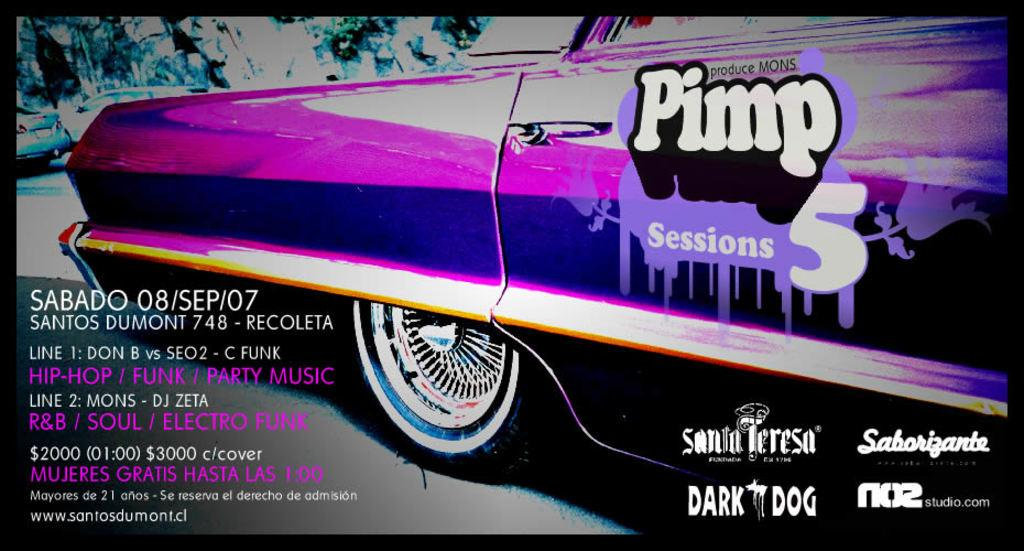What type of image is being displayed? The image contains an edited picture. What can be seen in the edited picture? There is a group of cars in the image. Where are the cars located? The cars are parked on the ground. What additional elements are present in the image? There is text and numbers in the image. What type of game is being played in the image? There is no game being played in the image; it features a group of parked cars. What kind of beam can be seen supporting the cars in the image? There is no beam present in the image; the cars are parked on the ground. 